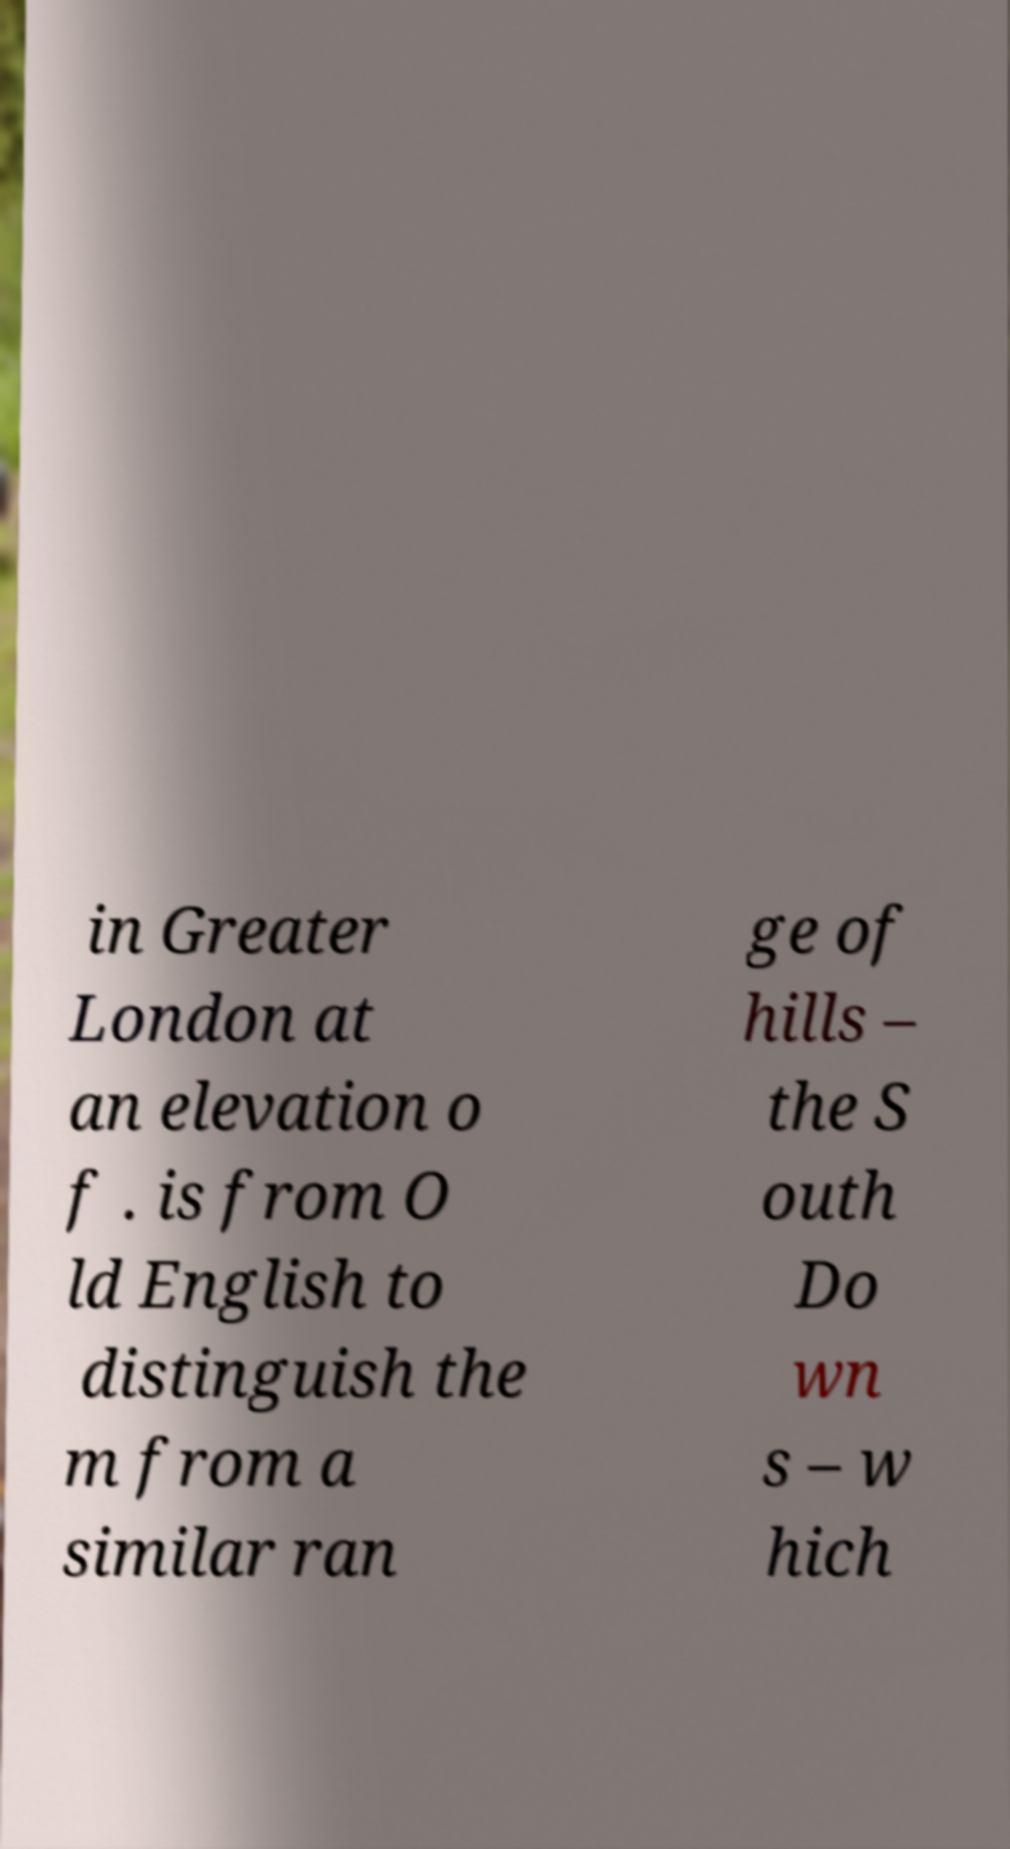Please read and relay the text visible in this image. What does it say? in Greater London at an elevation o f . is from O ld English to distinguish the m from a similar ran ge of hills – the S outh Do wn s – w hich 